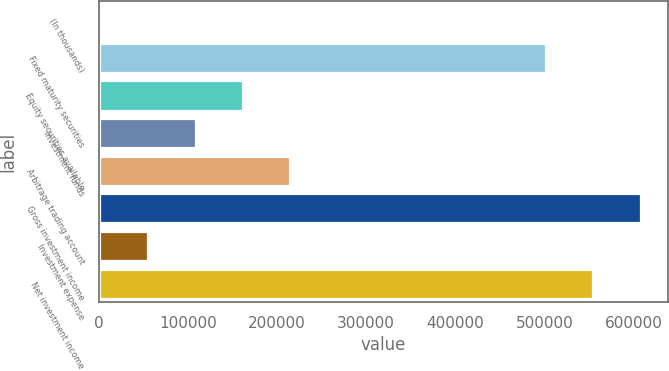Convert chart to OTSL. <chart><loc_0><loc_0><loc_500><loc_500><bar_chart><fcel>(In thousands)<fcel>Fixed maturity securities<fcel>Equity securities available<fcel>Investment funds<fcel>Arbitrage trading account<fcel>Gross investment income<fcel>Investment expense<fcel>Net investment income<nl><fcel>2010<fcel>501750<fcel>161632<fcel>108425<fcel>214840<fcel>608165<fcel>55217.5<fcel>554958<nl></chart> 